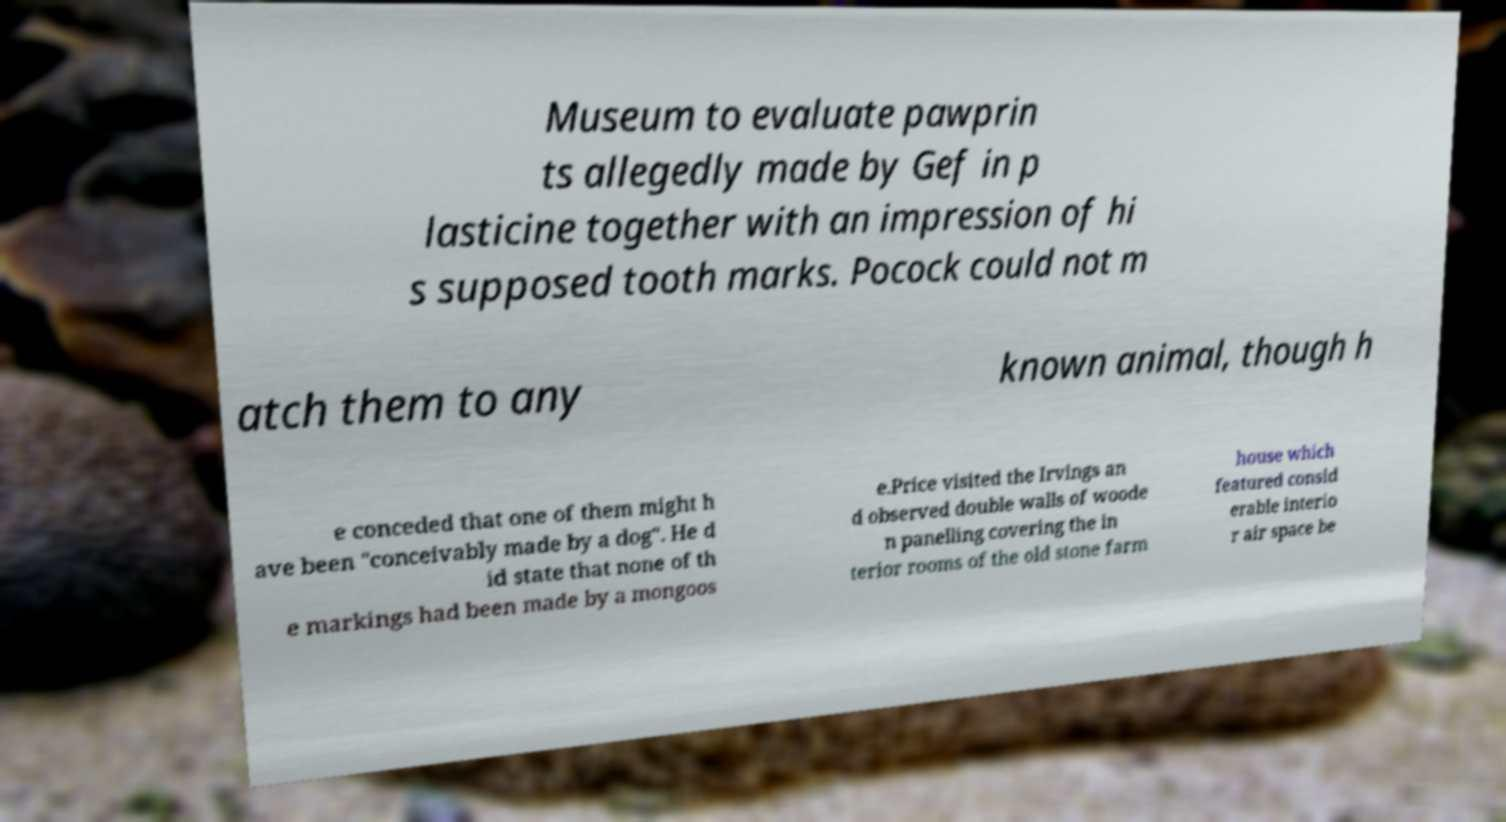Can you read and provide the text displayed in the image?This photo seems to have some interesting text. Can you extract and type it out for me? Museum to evaluate pawprin ts allegedly made by Gef in p lasticine together with an impression of hi s supposed tooth marks. Pocock could not m atch them to any known animal, though h e conceded that one of them might h ave been "conceivably made by a dog". He d id state that none of th e markings had been made by a mongoos e.Price visited the Irvings an d observed double walls of woode n panelling covering the in terior rooms of the old stone farm house which featured consid erable interio r air space be 